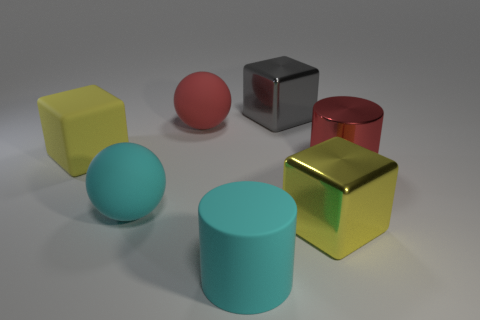Add 3 cyan cylinders. How many objects exist? 10 Subtract all cylinders. How many objects are left? 5 Subtract 0 green cylinders. How many objects are left? 7 Subtract all cyan cylinders. Subtract all yellow metal cubes. How many objects are left? 5 Add 7 large gray shiny cubes. How many large gray shiny cubes are left? 8 Add 7 tiny gray shiny cylinders. How many tiny gray shiny cylinders exist? 7 